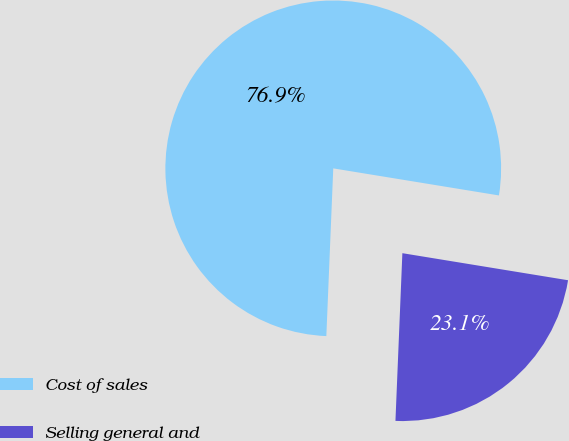Convert chart to OTSL. <chart><loc_0><loc_0><loc_500><loc_500><pie_chart><fcel>Cost of sales<fcel>Selling general and<nl><fcel>76.92%<fcel>23.08%<nl></chart> 